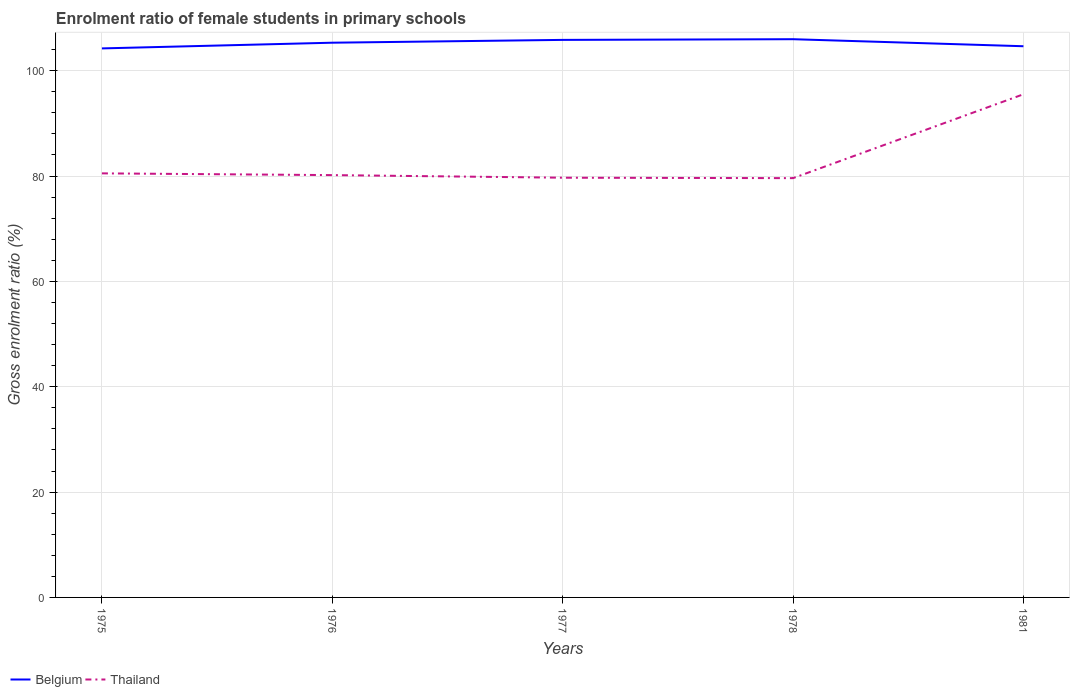Does the line corresponding to Thailand intersect with the line corresponding to Belgium?
Provide a short and direct response. No. Is the number of lines equal to the number of legend labels?
Keep it short and to the point. Yes. Across all years, what is the maximum enrolment ratio of female students in primary schools in Belgium?
Offer a very short reply. 104.23. In which year was the enrolment ratio of female students in primary schools in Thailand maximum?
Offer a very short reply. 1978. What is the total enrolment ratio of female students in primary schools in Thailand in the graph?
Your response must be concise. -15.84. What is the difference between the highest and the second highest enrolment ratio of female students in primary schools in Thailand?
Keep it short and to the point. 15.92. How many lines are there?
Your response must be concise. 2. How many years are there in the graph?
Ensure brevity in your answer.  5. What is the difference between two consecutive major ticks on the Y-axis?
Offer a very short reply. 20. Are the values on the major ticks of Y-axis written in scientific E-notation?
Give a very brief answer. No. How many legend labels are there?
Offer a terse response. 2. How are the legend labels stacked?
Offer a very short reply. Horizontal. What is the title of the graph?
Give a very brief answer. Enrolment ratio of female students in primary schools. Does "Tonga" appear as one of the legend labels in the graph?
Your answer should be very brief. No. What is the label or title of the X-axis?
Keep it short and to the point. Years. What is the Gross enrolment ratio (%) of Belgium in 1975?
Give a very brief answer. 104.23. What is the Gross enrolment ratio (%) in Thailand in 1975?
Provide a succinct answer. 80.51. What is the Gross enrolment ratio (%) in Belgium in 1976?
Your answer should be compact. 105.31. What is the Gross enrolment ratio (%) of Thailand in 1976?
Keep it short and to the point. 80.17. What is the Gross enrolment ratio (%) in Belgium in 1977?
Offer a terse response. 105.84. What is the Gross enrolment ratio (%) in Thailand in 1977?
Your answer should be compact. 79.68. What is the Gross enrolment ratio (%) of Belgium in 1978?
Provide a succinct answer. 105.97. What is the Gross enrolment ratio (%) in Thailand in 1978?
Offer a terse response. 79.6. What is the Gross enrolment ratio (%) of Belgium in 1981?
Give a very brief answer. 104.64. What is the Gross enrolment ratio (%) of Thailand in 1981?
Make the answer very short. 95.52. Across all years, what is the maximum Gross enrolment ratio (%) of Belgium?
Your response must be concise. 105.97. Across all years, what is the maximum Gross enrolment ratio (%) in Thailand?
Provide a short and direct response. 95.52. Across all years, what is the minimum Gross enrolment ratio (%) of Belgium?
Offer a terse response. 104.23. Across all years, what is the minimum Gross enrolment ratio (%) of Thailand?
Make the answer very short. 79.6. What is the total Gross enrolment ratio (%) in Belgium in the graph?
Give a very brief answer. 525.99. What is the total Gross enrolment ratio (%) of Thailand in the graph?
Offer a terse response. 415.47. What is the difference between the Gross enrolment ratio (%) in Belgium in 1975 and that in 1976?
Make the answer very short. -1.08. What is the difference between the Gross enrolment ratio (%) in Thailand in 1975 and that in 1976?
Your response must be concise. 0.33. What is the difference between the Gross enrolment ratio (%) in Belgium in 1975 and that in 1977?
Make the answer very short. -1.62. What is the difference between the Gross enrolment ratio (%) of Thailand in 1975 and that in 1977?
Provide a succinct answer. 0.83. What is the difference between the Gross enrolment ratio (%) in Belgium in 1975 and that in 1978?
Give a very brief answer. -1.75. What is the difference between the Gross enrolment ratio (%) in Thailand in 1975 and that in 1978?
Your answer should be very brief. 0.91. What is the difference between the Gross enrolment ratio (%) in Belgium in 1975 and that in 1981?
Your answer should be very brief. -0.41. What is the difference between the Gross enrolment ratio (%) in Thailand in 1975 and that in 1981?
Make the answer very short. -15.01. What is the difference between the Gross enrolment ratio (%) of Belgium in 1976 and that in 1977?
Keep it short and to the point. -0.54. What is the difference between the Gross enrolment ratio (%) of Thailand in 1976 and that in 1977?
Your response must be concise. 0.49. What is the difference between the Gross enrolment ratio (%) in Belgium in 1976 and that in 1978?
Your answer should be compact. -0.67. What is the difference between the Gross enrolment ratio (%) of Thailand in 1976 and that in 1978?
Offer a terse response. 0.58. What is the difference between the Gross enrolment ratio (%) in Belgium in 1976 and that in 1981?
Give a very brief answer. 0.67. What is the difference between the Gross enrolment ratio (%) of Thailand in 1976 and that in 1981?
Offer a terse response. -15.34. What is the difference between the Gross enrolment ratio (%) of Belgium in 1977 and that in 1978?
Provide a succinct answer. -0.13. What is the difference between the Gross enrolment ratio (%) of Thailand in 1977 and that in 1978?
Your response must be concise. 0.08. What is the difference between the Gross enrolment ratio (%) in Belgium in 1977 and that in 1981?
Offer a terse response. 1.2. What is the difference between the Gross enrolment ratio (%) in Thailand in 1977 and that in 1981?
Ensure brevity in your answer.  -15.84. What is the difference between the Gross enrolment ratio (%) in Belgium in 1978 and that in 1981?
Your answer should be very brief. 1.33. What is the difference between the Gross enrolment ratio (%) of Thailand in 1978 and that in 1981?
Ensure brevity in your answer.  -15.92. What is the difference between the Gross enrolment ratio (%) in Belgium in 1975 and the Gross enrolment ratio (%) in Thailand in 1976?
Your response must be concise. 24.05. What is the difference between the Gross enrolment ratio (%) in Belgium in 1975 and the Gross enrolment ratio (%) in Thailand in 1977?
Give a very brief answer. 24.55. What is the difference between the Gross enrolment ratio (%) of Belgium in 1975 and the Gross enrolment ratio (%) of Thailand in 1978?
Provide a succinct answer. 24.63. What is the difference between the Gross enrolment ratio (%) in Belgium in 1975 and the Gross enrolment ratio (%) in Thailand in 1981?
Your answer should be very brief. 8.71. What is the difference between the Gross enrolment ratio (%) in Belgium in 1976 and the Gross enrolment ratio (%) in Thailand in 1977?
Your answer should be very brief. 25.63. What is the difference between the Gross enrolment ratio (%) of Belgium in 1976 and the Gross enrolment ratio (%) of Thailand in 1978?
Make the answer very short. 25.71. What is the difference between the Gross enrolment ratio (%) in Belgium in 1976 and the Gross enrolment ratio (%) in Thailand in 1981?
Offer a terse response. 9.79. What is the difference between the Gross enrolment ratio (%) in Belgium in 1977 and the Gross enrolment ratio (%) in Thailand in 1978?
Keep it short and to the point. 26.25. What is the difference between the Gross enrolment ratio (%) of Belgium in 1977 and the Gross enrolment ratio (%) of Thailand in 1981?
Provide a short and direct response. 10.33. What is the difference between the Gross enrolment ratio (%) of Belgium in 1978 and the Gross enrolment ratio (%) of Thailand in 1981?
Your response must be concise. 10.46. What is the average Gross enrolment ratio (%) of Belgium per year?
Your answer should be compact. 105.2. What is the average Gross enrolment ratio (%) of Thailand per year?
Your response must be concise. 83.09. In the year 1975, what is the difference between the Gross enrolment ratio (%) in Belgium and Gross enrolment ratio (%) in Thailand?
Provide a short and direct response. 23.72. In the year 1976, what is the difference between the Gross enrolment ratio (%) of Belgium and Gross enrolment ratio (%) of Thailand?
Provide a short and direct response. 25.13. In the year 1977, what is the difference between the Gross enrolment ratio (%) of Belgium and Gross enrolment ratio (%) of Thailand?
Provide a short and direct response. 26.16. In the year 1978, what is the difference between the Gross enrolment ratio (%) of Belgium and Gross enrolment ratio (%) of Thailand?
Your answer should be very brief. 26.38. In the year 1981, what is the difference between the Gross enrolment ratio (%) of Belgium and Gross enrolment ratio (%) of Thailand?
Provide a succinct answer. 9.12. What is the ratio of the Gross enrolment ratio (%) in Belgium in 1975 to that in 1976?
Provide a short and direct response. 0.99. What is the ratio of the Gross enrolment ratio (%) in Belgium in 1975 to that in 1977?
Offer a very short reply. 0.98. What is the ratio of the Gross enrolment ratio (%) of Thailand in 1975 to that in 1977?
Your answer should be compact. 1.01. What is the ratio of the Gross enrolment ratio (%) of Belgium in 1975 to that in 1978?
Keep it short and to the point. 0.98. What is the ratio of the Gross enrolment ratio (%) of Thailand in 1975 to that in 1978?
Give a very brief answer. 1.01. What is the ratio of the Gross enrolment ratio (%) in Belgium in 1975 to that in 1981?
Offer a terse response. 1. What is the ratio of the Gross enrolment ratio (%) of Thailand in 1975 to that in 1981?
Provide a succinct answer. 0.84. What is the ratio of the Gross enrolment ratio (%) in Thailand in 1976 to that in 1977?
Your response must be concise. 1.01. What is the ratio of the Gross enrolment ratio (%) of Belgium in 1976 to that in 1981?
Provide a short and direct response. 1.01. What is the ratio of the Gross enrolment ratio (%) of Thailand in 1976 to that in 1981?
Make the answer very short. 0.84. What is the ratio of the Gross enrolment ratio (%) of Thailand in 1977 to that in 1978?
Give a very brief answer. 1. What is the ratio of the Gross enrolment ratio (%) of Belgium in 1977 to that in 1981?
Your response must be concise. 1.01. What is the ratio of the Gross enrolment ratio (%) of Thailand in 1977 to that in 1981?
Your response must be concise. 0.83. What is the ratio of the Gross enrolment ratio (%) of Belgium in 1978 to that in 1981?
Your answer should be compact. 1.01. What is the ratio of the Gross enrolment ratio (%) in Thailand in 1978 to that in 1981?
Your answer should be compact. 0.83. What is the difference between the highest and the second highest Gross enrolment ratio (%) of Belgium?
Your answer should be very brief. 0.13. What is the difference between the highest and the second highest Gross enrolment ratio (%) in Thailand?
Provide a succinct answer. 15.01. What is the difference between the highest and the lowest Gross enrolment ratio (%) in Belgium?
Offer a terse response. 1.75. What is the difference between the highest and the lowest Gross enrolment ratio (%) in Thailand?
Give a very brief answer. 15.92. 